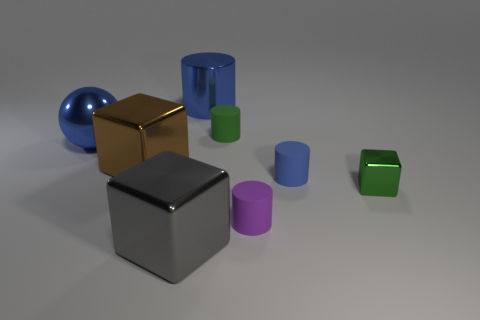Does the small rubber cylinder behind the sphere have the same color as the metallic thing right of the green rubber object?
Your answer should be compact. Yes. Is there a big ball that has the same color as the metal cylinder?
Make the answer very short. Yes. What material is the small cylinder that is the same color as the big metal cylinder?
Give a very brief answer. Rubber. There is a tiny thing behind the blue ball; what shape is it?
Your answer should be compact. Cylinder. Are there fewer gray objects behind the large brown block than cylinders that are on the right side of the purple matte cylinder?
Make the answer very short. Yes. Are the large block that is in front of the tiny green shiny object and the tiny green object behind the tiny blue matte cylinder made of the same material?
Your answer should be very brief. No. The green shiny thing is what shape?
Provide a short and direct response. Cube. Is the number of tiny green blocks that are behind the big blue metallic cylinder greater than the number of big blue balls right of the shiny ball?
Provide a succinct answer. No. There is a brown metallic object that is behind the purple rubber cylinder; is its shape the same as the tiny green shiny object that is on the right side of the tiny purple rubber thing?
Ensure brevity in your answer.  Yes. What number of other objects are the same size as the sphere?
Your response must be concise. 3. 